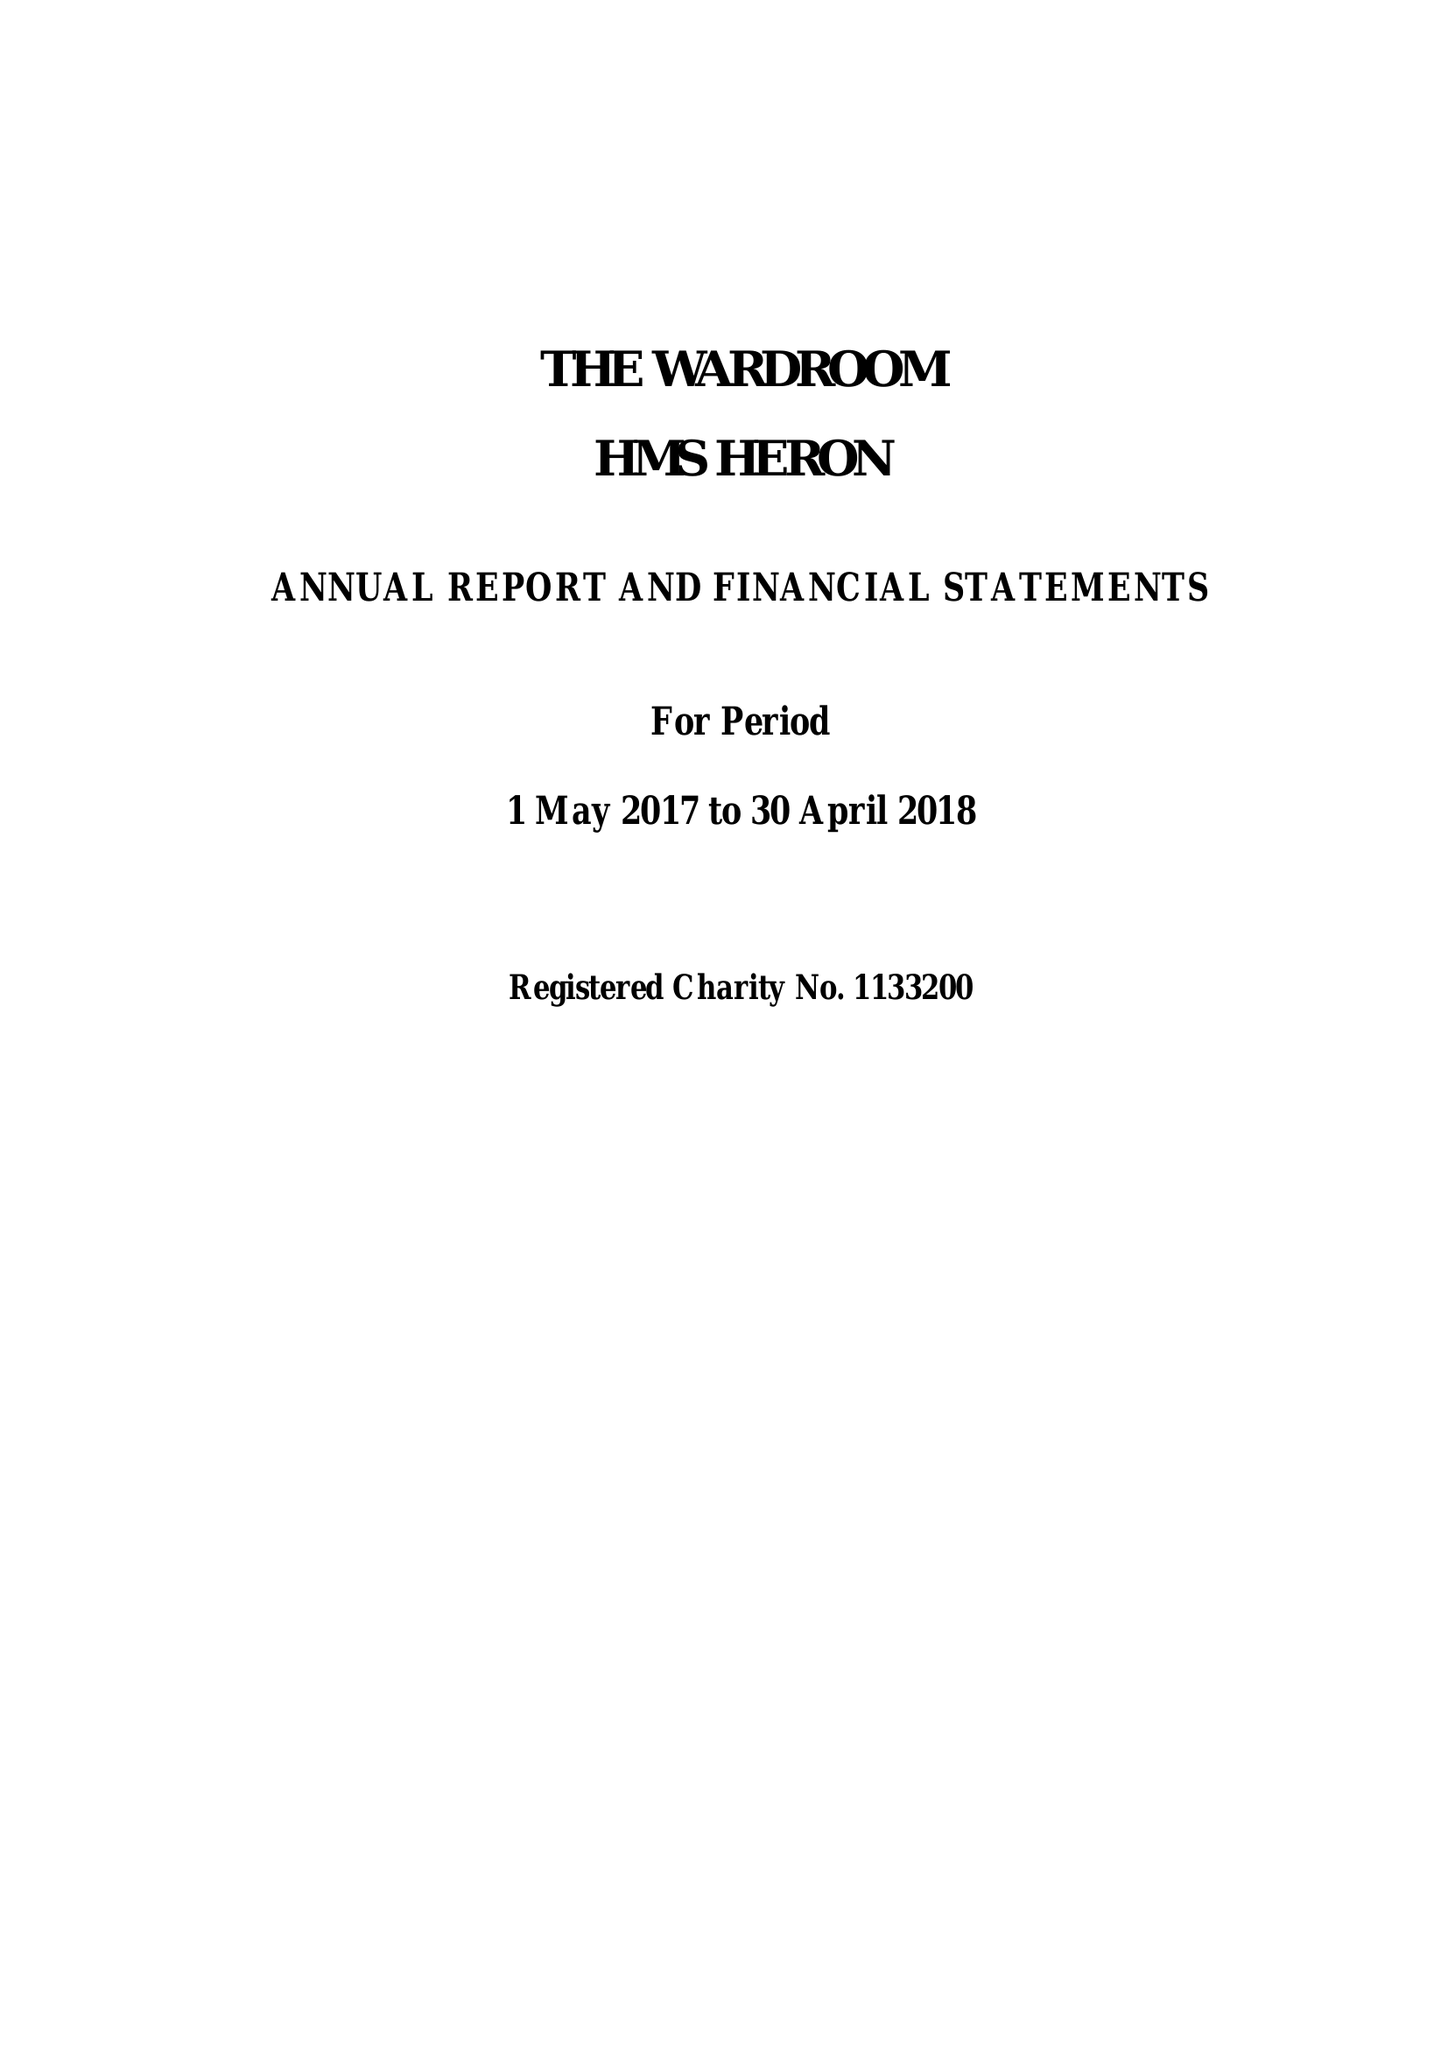What is the value for the address__postcode?
Answer the question using a single word or phrase. BA22 8HT 